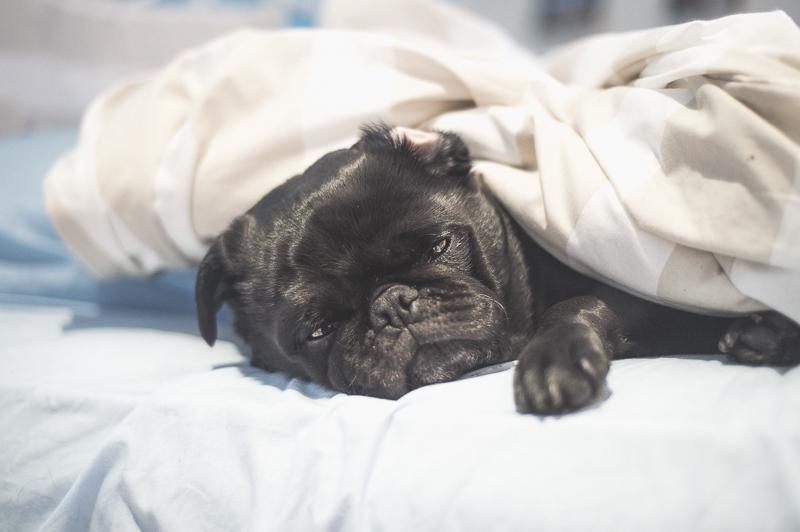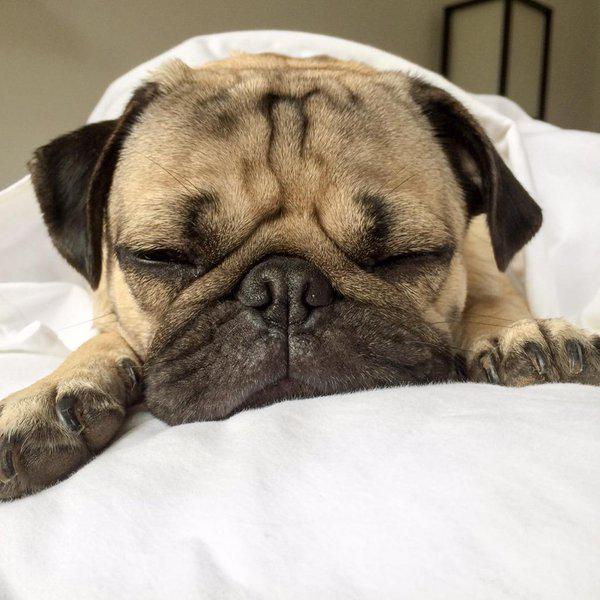The first image is the image on the left, the second image is the image on the right. Evaluate the accuracy of this statement regarding the images: "A black pug lying with its head sideways is peeking out from under a sheet in the left image.". Is it true? Answer yes or no. Yes. The first image is the image on the left, the second image is the image on the right. Analyze the images presented: Is the assertion "In the right image, the pug has no paws sticking out of the blanket." valid? Answer yes or no. No. 